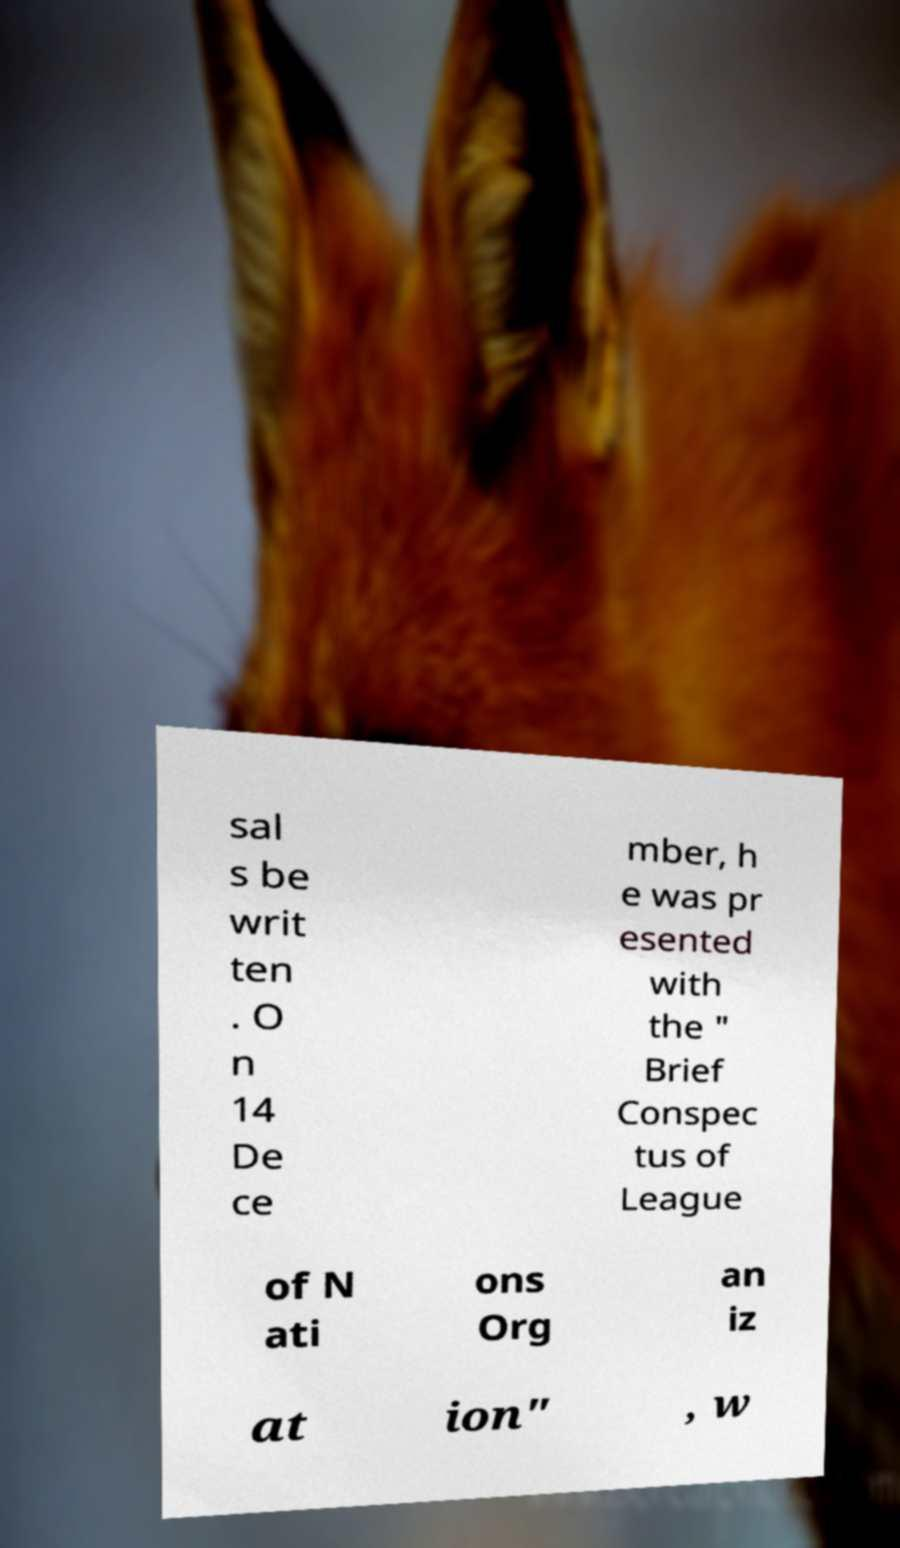For documentation purposes, I need the text within this image transcribed. Could you provide that? sal s be writ ten . O n 14 De ce mber, h e was pr esented with the " Brief Conspec tus of League of N ati ons Org an iz at ion" , w 